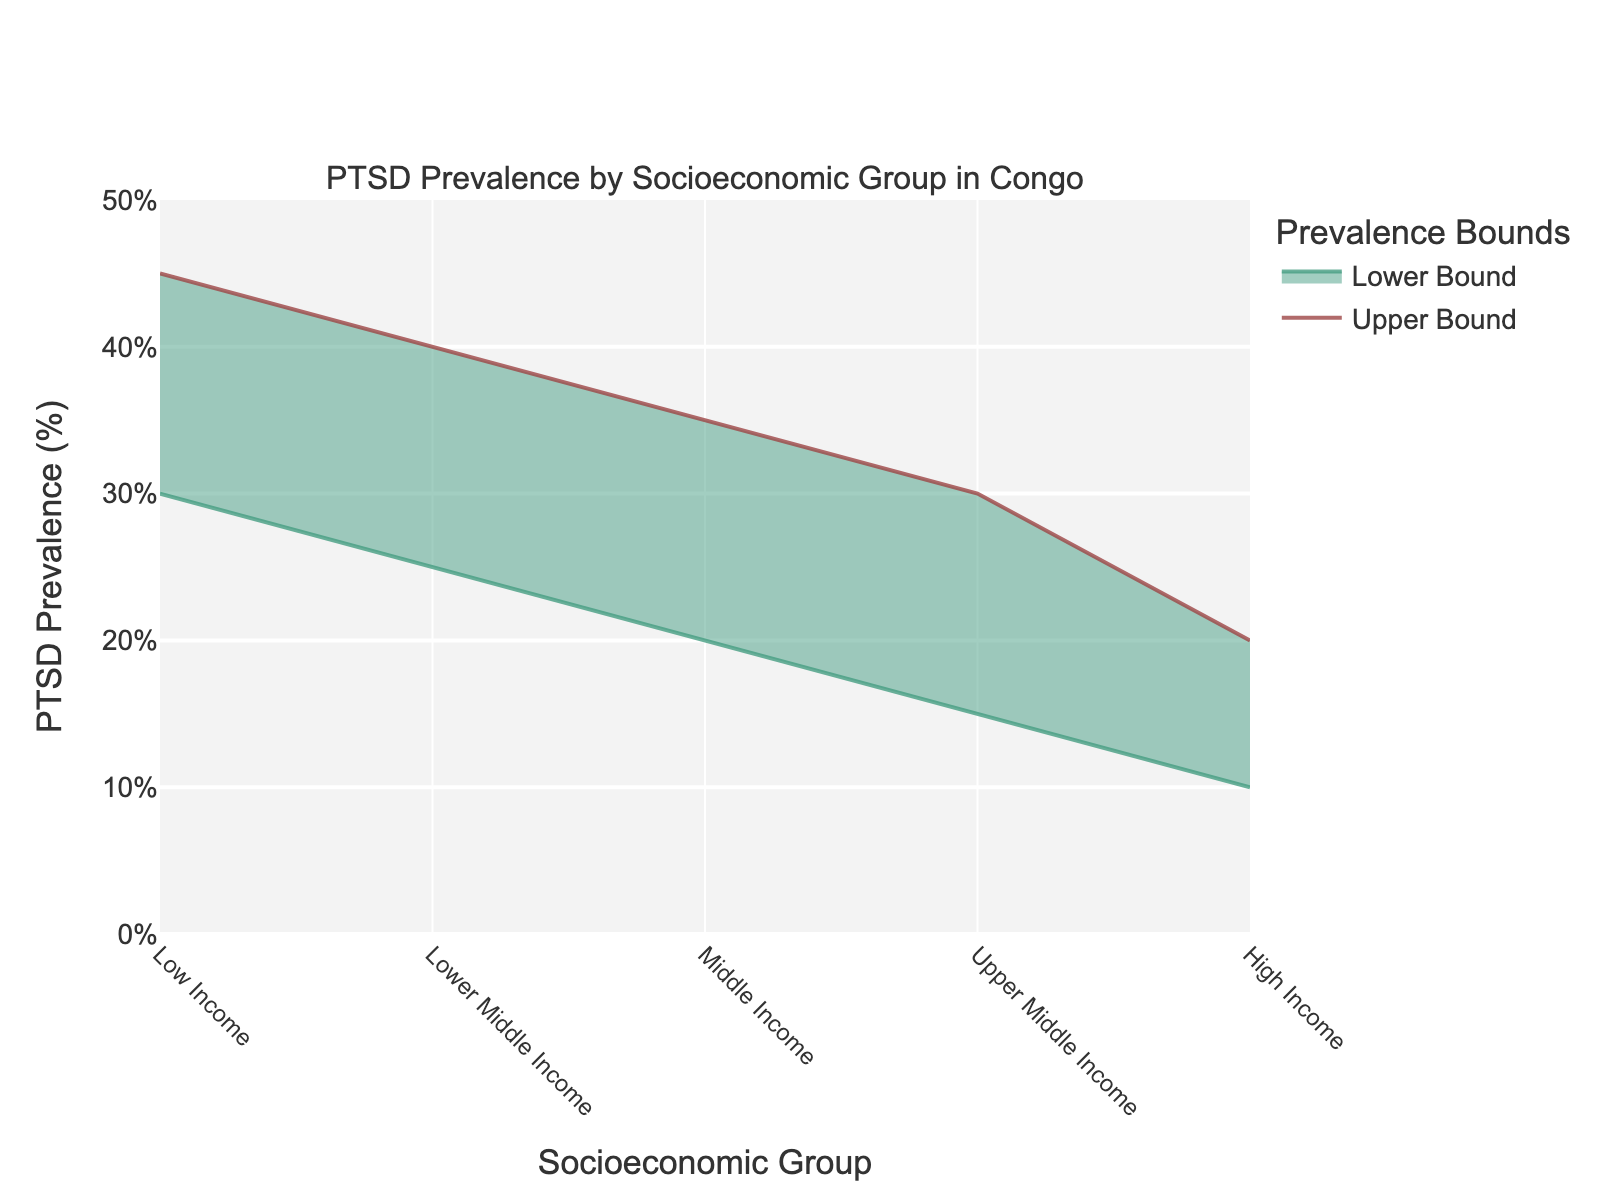What is the title of the chart? The title is located at the top of the chart. It provides a summary of the chart's content.
Answer: PTSD Prevalence by Socioeconomic Group in Congo What is the range of PTSD prevalence for the Low Income group? Look at the y-values for the Low Income group. The lower bound is 30 and the upper bound is 45.
Answer: 30% - 45% Which socioeconomic group has the lowest upper bound of PTSD prevalence? Compare the upper bounds of all groups. The High Income group has the lowest upper bound of 20.
Answer: High Income How does the PTSD prevalence range for Middle Income compare to Upper Middle Income? Look at both ranges: Middle Income is 20-35% and Upper Middle Income is 15-30%. Note the difference between lower and upper bounds of both ranges.
Answer: Middle Income has higher upper and lower bounds What is the difference in the lower bound of PTSD prevalence between the Lower Middle Income and High Income groups? Subtract the lower bound of High Income (10) from the lower bound of Lower Middle Income (25).
Answer: 15% Which group shows the widest range of PTSD prevalence? Calculate the range by subtracting the lower bound from the upper bound for each group. The Low Income group has the widest range (45-30 = 15).
Answer: Low Income What is the average range of PTSD prevalence for the Upper Middle Income and High Income groups? Calculate the midpoint for each group: Upper Middle Income (22.5%), and High Income (15%). Then find the average of these midpoints: (22.5 + 15) / 2.
Answer: 18.75% Which group experiences the lowest lower bound of PTSD prevalence? Find the group with the lowest lower bound value on the y-axis. The High Income group has the lowest lower bound of 10.
Answer: High Income How much higher is the upper bound of PTSD prevalence for the Low Income group compared to the High Income group? Subtract the upper bound of High Income (20) from the upper bound of Low Income (45).
Answer: 25% 